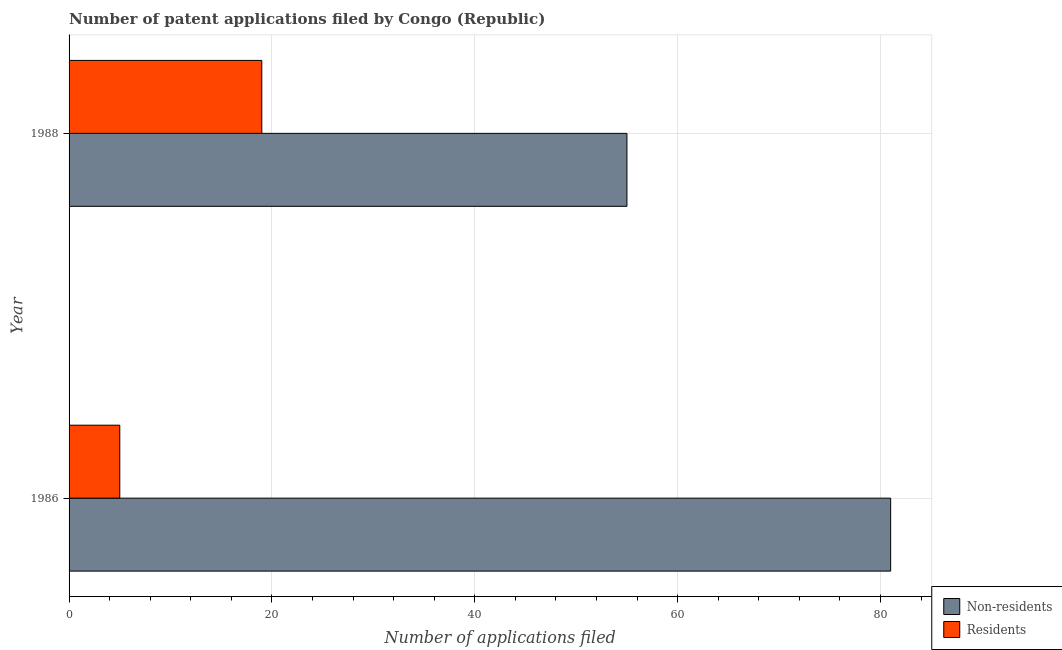How many different coloured bars are there?
Offer a very short reply. 2. How many bars are there on the 2nd tick from the bottom?
Give a very brief answer. 2. In how many cases, is the number of bars for a given year not equal to the number of legend labels?
Make the answer very short. 0. What is the number of patent applications by non residents in 1986?
Your answer should be compact. 81. Across all years, what is the maximum number of patent applications by non residents?
Provide a short and direct response. 81. Across all years, what is the minimum number of patent applications by non residents?
Give a very brief answer. 55. In which year was the number of patent applications by non residents maximum?
Your answer should be compact. 1986. What is the total number of patent applications by non residents in the graph?
Your answer should be compact. 136. What is the difference between the number of patent applications by residents in 1986 and that in 1988?
Make the answer very short. -14. What is the difference between the number of patent applications by residents in 1988 and the number of patent applications by non residents in 1986?
Your answer should be compact. -62. In the year 1988, what is the difference between the number of patent applications by residents and number of patent applications by non residents?
Offer a very short reply. -36. In how many years, is the number of patent applications by non residents greater than 36 ?
Provide a succinct answer. 2. What is the ratio of the number of patent applications by residents in 1986 to that in 1988?
Provide a short and direct response. 0.26. Is the number of patent applications by non residents in 1986 less than that in 1988?
Offer a very short reply. No. Is the difference between the number of patent applications by residents in 1986 and 1988 greater than the difference between the number of patent applications by non residents in 1986 and 1988?
Ensure brevity in your answer.  No. What does the 1st bar from the top in 1986 represents?
Ensure brevity in your answer.  Residents. What does the 2nd bar from the bottom in 1988 represents?
Your answer should be compact. Residents. How many bars are there?
Keep it short and to the point. 4. How many years are there in the graph?
Make the answer very short. 2. What is the difference between two consecutive major ticks on the X-axis?
Offer a terse response. 20. Does the graph contain any zero values?
Make the answer very short. No. Does the graph contain grids?
Provide a succinct answer. Yes. How many legend labels are there?
Give a very brief answer. 2. How are the legend labels stacked?
Provide a succinct answer. Vertical. What is the title of the graph?
Offer a very short reply. Number of patent applications filed by Congo (Republic). Does "Tetanus" appear as one of the legend labels in the graph?
Keep it short and to the point. No. What is the label or title of the X-axis?
Offer a very short reply. Number of applications filed. What is the label or title of the Y-axis?
Provide a short and direct response. Year. What is the Number of applications filed in Residents in 1986?
Provide a short and direct response. 5. What is the Number of applications filed of Residents in 1988?
Your answer should be compact. 19. Across all years, what is the maximum Number of applications filed in Non-residents?
Ensure brevity in your answer.  81. Across all years, what is the maximum Number of applications filed in Residents?
Ensure brevity in your answer.  19. Across all years, what is the minimum Number of applications filed of Non-residents?
Make the answer very short. 55. What is the total Number of applications filed in Non-residents in the graph?
Offer a very short reply. 136. What is the difference between the Number of applications filed in Non-residents in 1986 and that in 1988?
Your response must be concise. 26. What is the difference between the Number of applications filed in Residents in 1986 and that in 1988?
Make the answer very short. -14. What is the difference between the Number of applications filed in Non-residents in 1986 and the Number of applications filed in Residents in 1988?
Ensure brevity in your answer.  62. What is the average Number of applications filed in Non-residents per year?
Ensure brevity in your answer.  68. What is the average Number of applications filed in Residents per year?
Keep it short and to the point. 12. In the year 1986, what is the difference between the Number of applications filed of Non-residents and Number of applications filed of Residents?
Offer a terse response. 76. In the year 1988, what is the difference between the Number of applications filed in Non-residents and Number of applications filed in Residents?
Your response must be concise. 36. What is the ratio of the Number of applications filed in Non-residents in 1986 to that in 1988?
Your answer should be compact. 1.47. What is the ratio of the Number of applications filed of Residents in 1986 to that in 1988?
Your response must be concise. 0.26. What is the difference between the highest and the second highest Number of applications filed of Residents?
Offer a terse response. 14. 